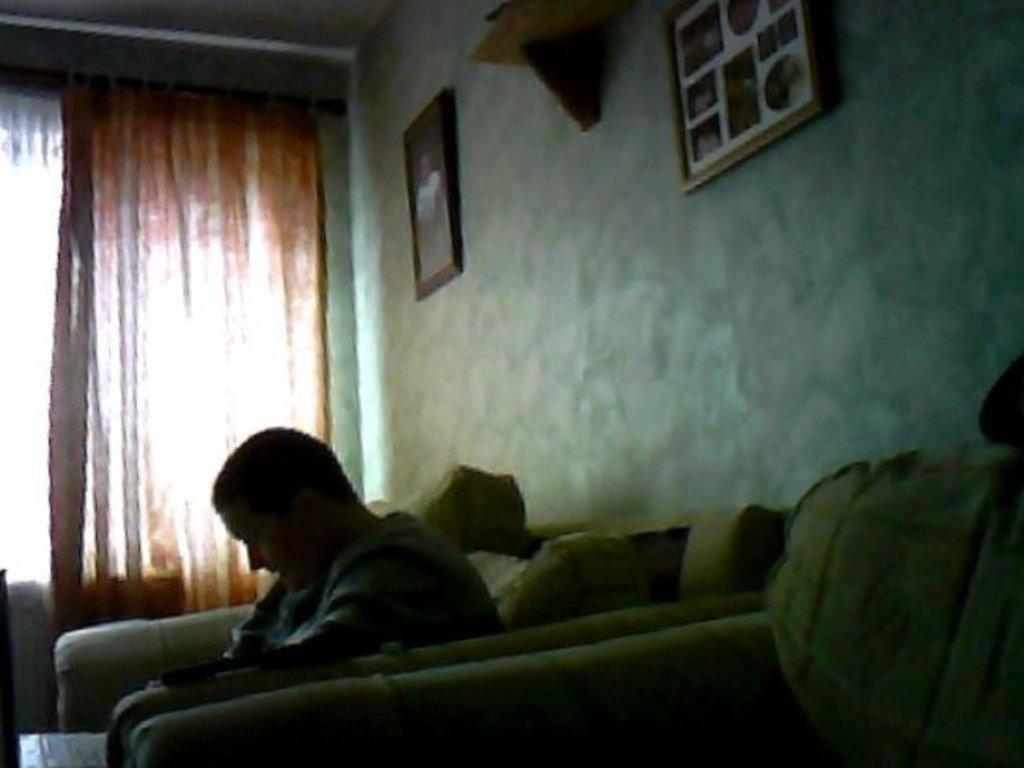Describe this image in one or two sentences. In this image, we can see a person is sitting on a couch. Here we can see cushions, wall, photo frames, decorative object and curtain. 